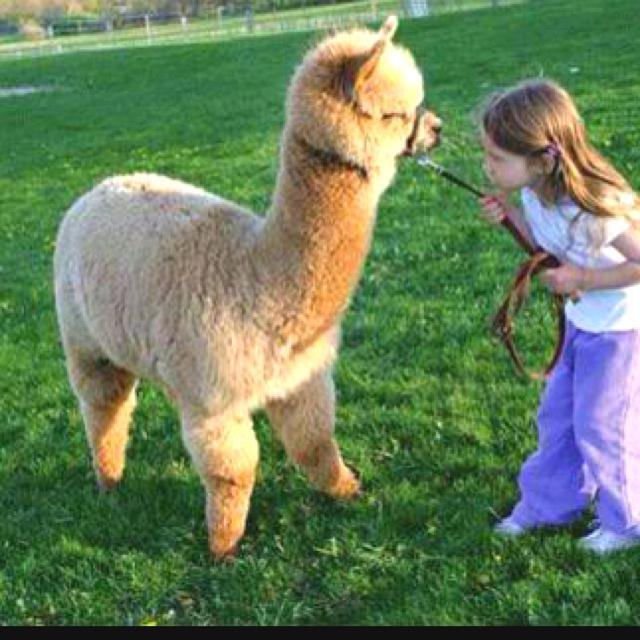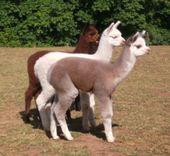The first image is the image on the left, the second image is the image on the right. Given the left and right images, does the statement "The right image contains exactly three llamas with heads close together, one of them white, and the left image shows two heads close together, at least one belonging to a light-colored llama." hold true? Answer yes or no. Yes. The first image is the image on the left, the second image is the image on the right. For the images displayed, is the sentence "There are at most 4 llamas in the pair of images." factually correct? Answer yes or no. Yes. 